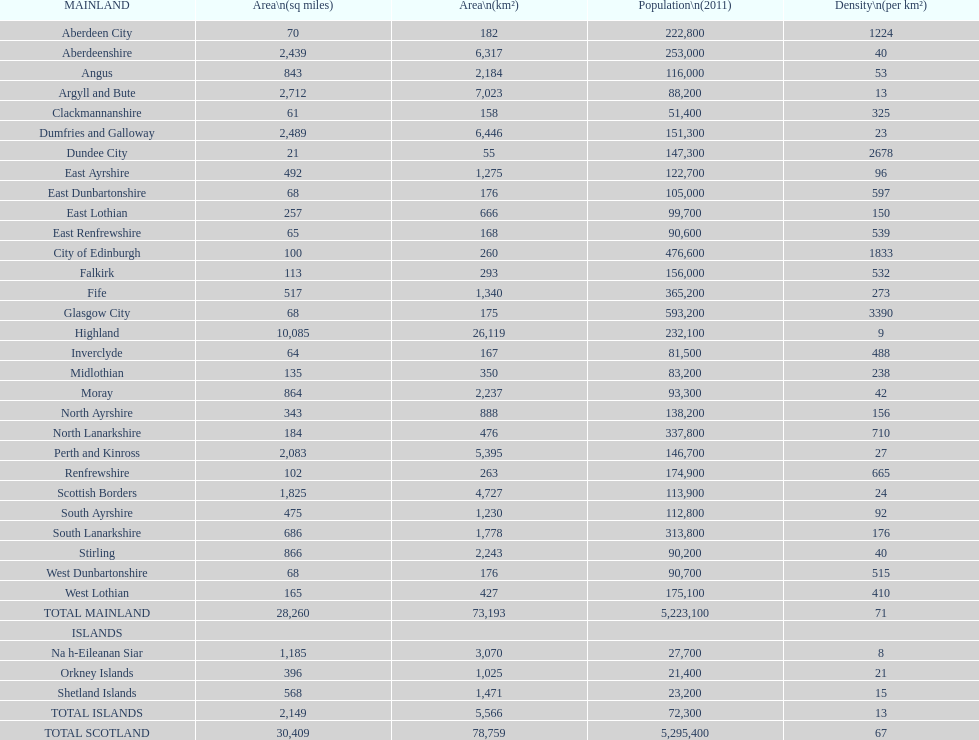Can you give me this table as a dict? {'header': ['MAINLAND', 'Area\\n(sq miles)', 'Area\\n(km²)', 'Population\\n(2011)', 'Density\\n(per km²)'], 'rows': [['Aberdeen City', '70', '182', '222,800', '1224'], ['Aberdeenshire', '2,439', '6,317', '253,000', '40'], ['Angus', '843', '2,184', '116,000', '53'], ['Argyll and Bute', '2,712', '7,023', '88,200', '13'], ['Clackmannanshire', '61', '158', '51,400', '325'], ['Dumfries and Galloway', '2,489', '6,446', '151,300', '23'], ['Dundee City', '21', '55', '147,300', '2678'], ['East Ayrshire', '492', '1,275', '122,700', '96'], ['East Dunbartonshire', '68', '176', '105,000', '597'], ['East Lothian', '257', '666', '99,700', '150'], ['East Renfrewshire', '65', '168', '90,600', '539'], ['City of Edinburgh', '100', '260', '476,600', '1833'], ['Falkirk', '113', '293', '156,000', '532'], ['Fife', '517', '1,340', '365,200', '273'], ['Glasgow City', '68', '175', '593,200', '3390'], ['Highland', '10,085', '26,119', '232,100', '9'], ['Inverclyde', '64', '167', '81,500', '488'], ['Midlothian', '135', '350', '83,200', '238'], ['Moray', '864', '2,237', '93,300', '42'], ['North Ayrshire', '343', '888', '138,200', '156'], ['North Lanarkshire', '184', '476', '337,800', '710'], ['Perth and Kinross', '2,083', '5,395', '146,700', '27'], ['Renfrewshire', '102', '263', '174,900', '665'], ['Scottish Borders', '1,825', '4,727', '113,900', '24'], ['South Ayrshire', '475', '1,230', '112,800', '92'], ['South Lanarkshire', '686', '1,778', '313,800', '176'], ['Stirling', '866', '2,243', '90,200', '40'], ['West Dunbartonshire', '68', '176', '90,700', '515'], ['West Lothian', '165', '427', '175,100', '410'], ['TOTAL MAINLAND', '28,260', '73,193', '5,223,100', '71'], ['ISLANDS', '', '', '', ''], ['Na h-Eileanan Siar', '1,185', '3,070', '27,700', '8'], ['Orkney Islands', '396', '1,025', '21,400', '21'], ['Shetland Islands', '568', '1,471', '23,200', '15'], ['TOTAL ISLANDS', '2,149', '5,566', '72,300', '13'], ['TOTAL SCOTLAND', '30,409', '78,759', '5,295,400', '67']]} What is the variation in square miles from angus to fife? 326. 